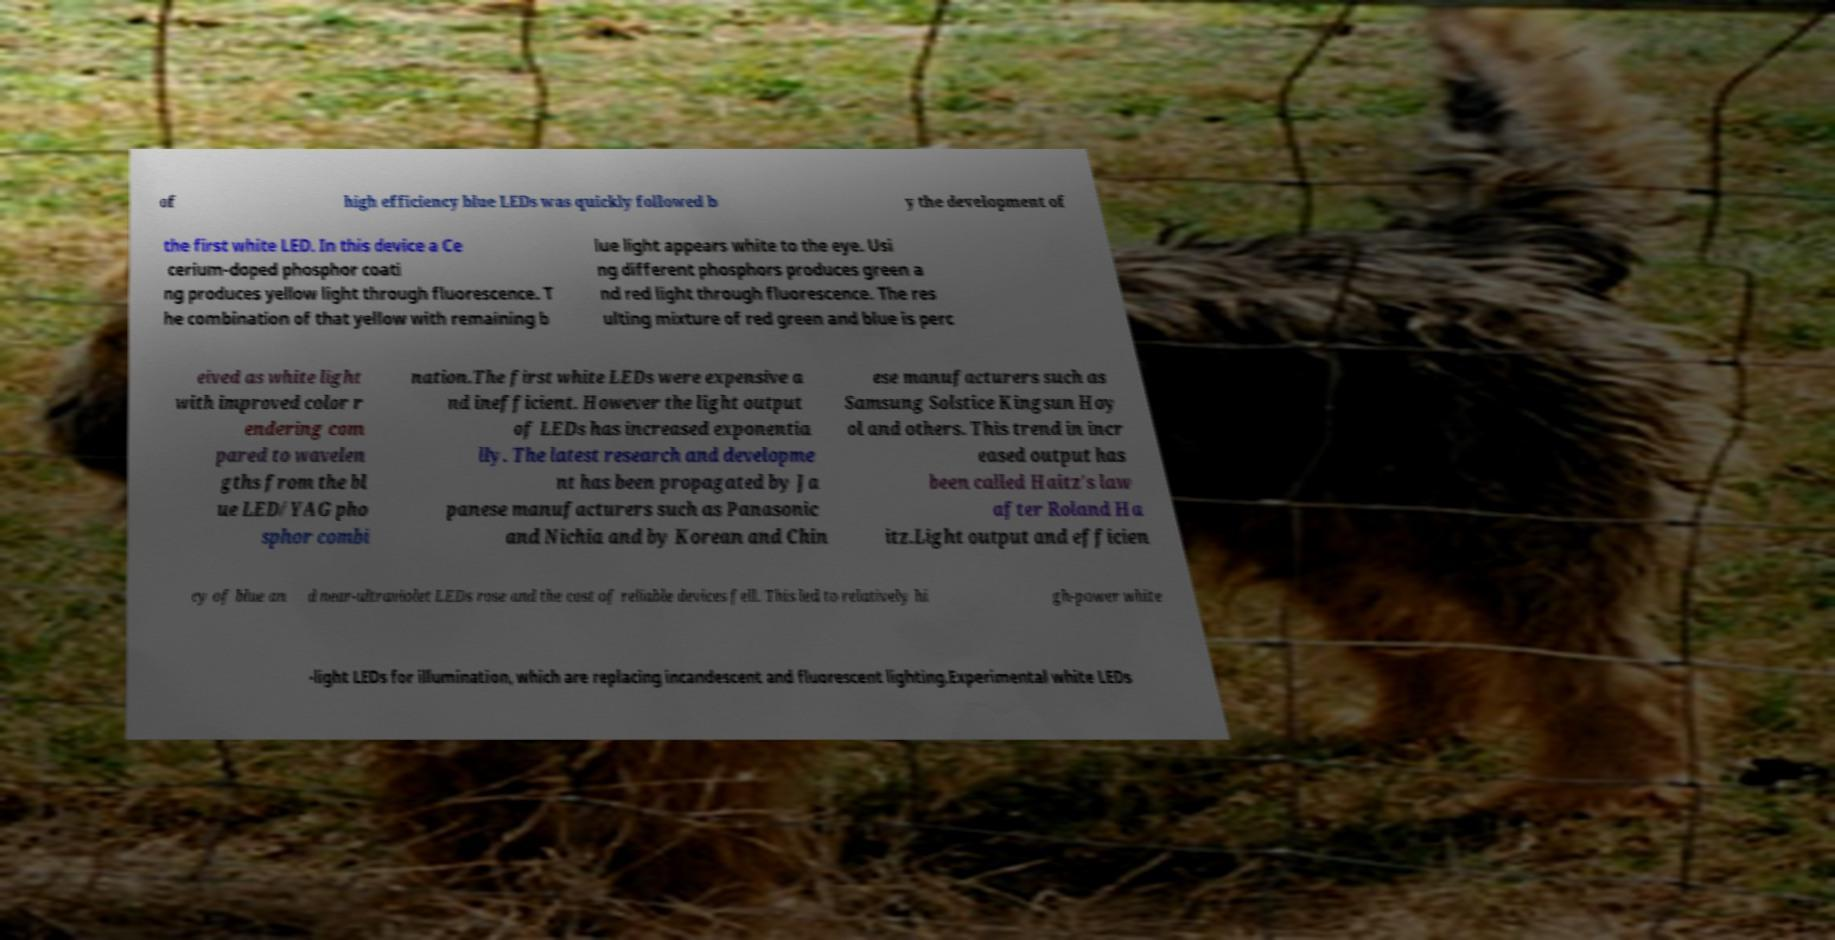Please identify and transcribe the text found in this image. of high efficiency blue LEDs was quickly followed b y the development of the first white LED. In this device a Ce cerium-doped phosphor coati ng produces yellow light through fluorescence. T he combination of that yellow with remaining b lue light appears white to the eye. Usi ng different phosphors produces green a nd red light through fluorescence. The res ulting mixture of red green and blue is perc eived as white light with improved color r endering com pared to wavelen gths from the bl ue LED/YAG pho sphor combi nation.The first white LEDs were expensive a nd inefficient. However the light output of LEDs has increased exponentia lly. The latest research and developme nt has been propagated by Ja panese manufacturers such as Panasonic and Nichia and by Korean and Chin ese manufacturers such as Samsung Solstice Kingsun Hoy ol and others. This trend in incr eased output has been called Haitz's law after Roland Ha itz.Light output and efficien cy of blue an d near-ultraviolet LEDs rose and the cost of reliable devices fell. This led to relatively hi gh-power white -light LEDs for illumination, which are replacing incandescent and fluorescent lighting.Experimental white LEDs 